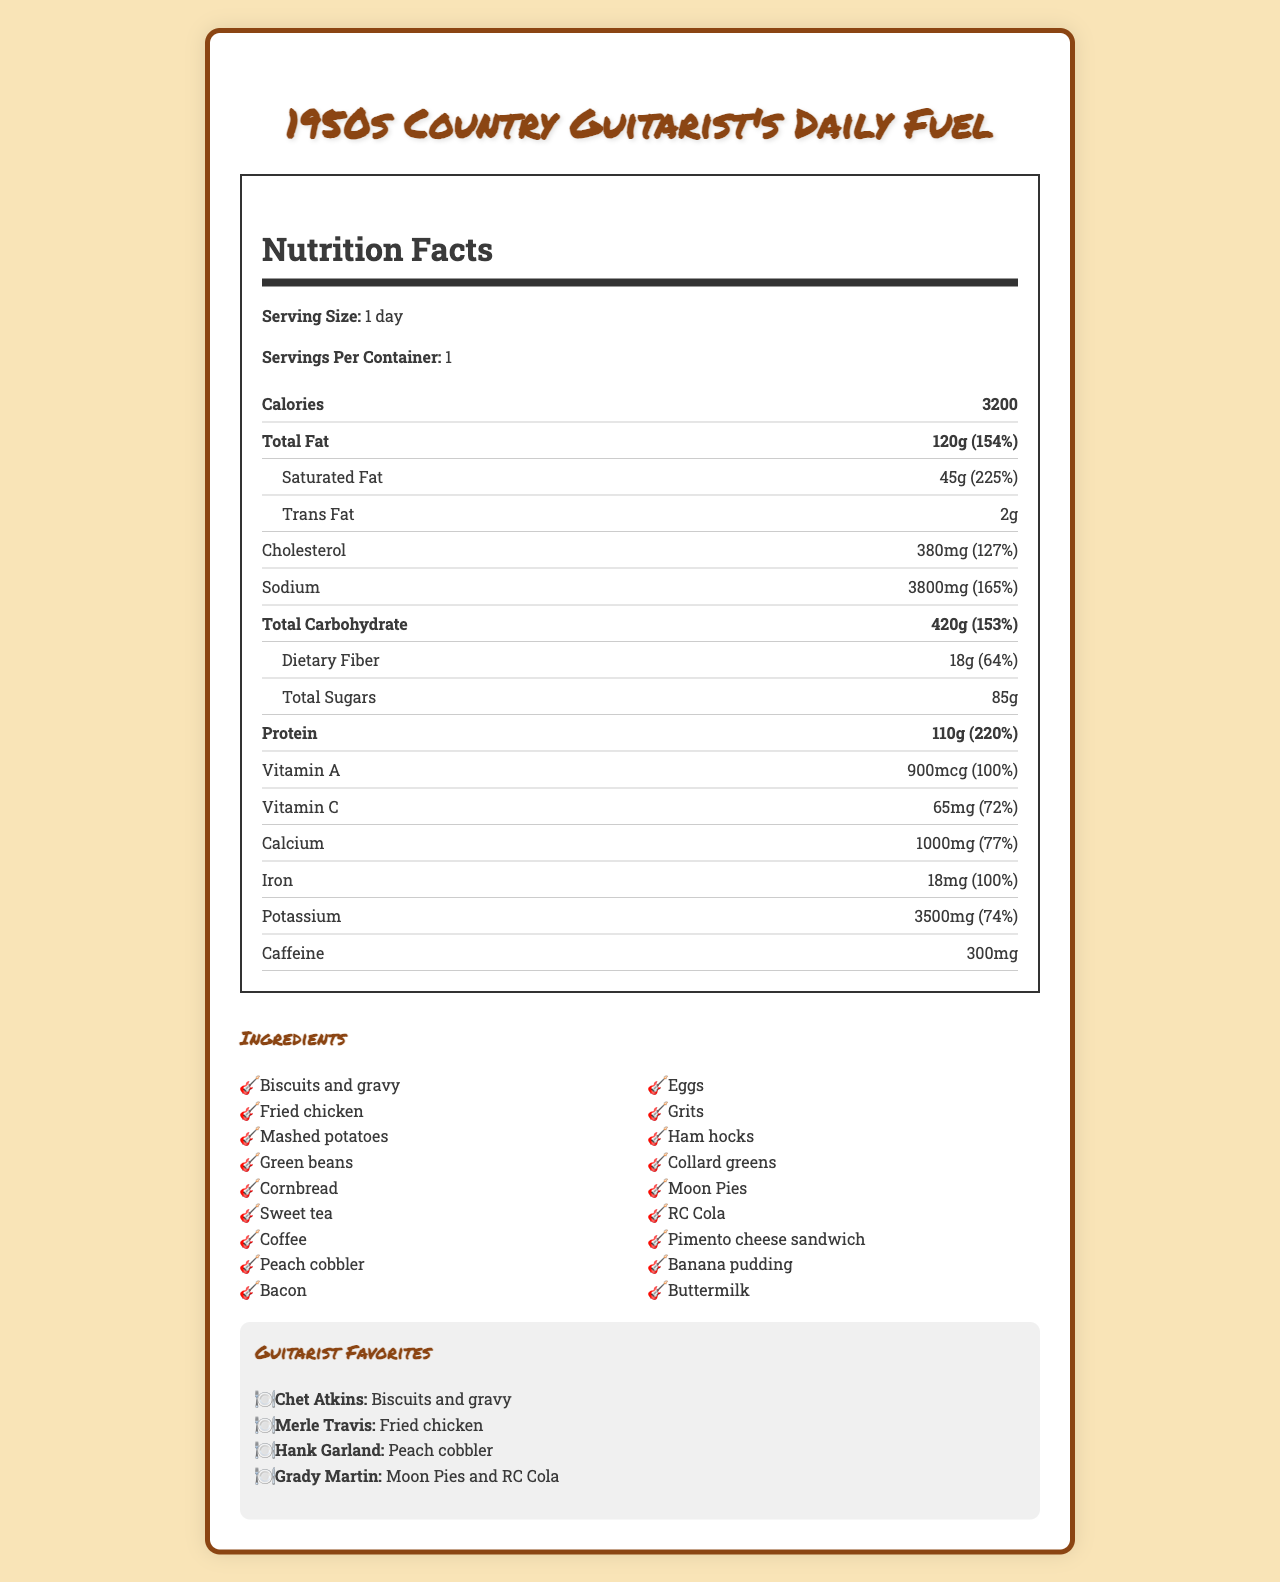what is the serving size? The document states that the serving size is "1 day."
Answer: 1 day how many calories does the 1950s country guitarist's daily fuel contain? The document lists the total calories as 3200.
Answer: 3200 what are the ingredients in this daily fuel? The Ingredients section lists all the ingredients included in the daily fuel.
Answer: Biscuits and gravy, Fried chicken, Mashed potatoes, Green beans, Cornbread, Sweet tea, Coffee, Peach cobbler, Bacon, Eggs, Grits, Ham hocks, Collard greens, Moon Pies, RC Cola, Pimento cheese sandwich, Banana pudding, Buttermilk which vitamin is provided at 100% daily value? The document indicates that Vitamin A is provided at 100% of the daily value with an amount of 900 mcg.
Answer: Vitamin A who preferred Moon Pies and RC Cola? In the Guitarist Favorites section, it mentions that Grady Martin's favorites are Moon Pies and RC Cola.
Answer: Grady Martin which post-show snack is listed in the document? 
A. Moon Pies
B. Biscuits and gravy
C. Banana pudding
D. Fried chicken The Post Show Snack section indicates that Banana pudding is the post-show snack.
Answer: C which guitarist's favorite is fried chicken?
I. Grady Martin
II. Hank Garland
III. Merle Travis In the Guitarist Favorites section, Merle Travis is listed as preferring fried chicken.
Answer: III is the sodium content higher than the cholesterol content? The sodium content is 3800 mg, which is higher than the cholesterol content of 380 mg.
Answer: Yes summarize the main idea of the document. The document contains comprehensive nutrition information, including calories, fats, proteins, vitamins, and minerals, along with a list of foods and beverages typical of a 1950s country musician's diet, favorite food items of specific guitarists, and essential meals and performance boosters.
Answer: The document provides detailed nutrition facts and ingredients for a typical daily diet of a 1950s country guitarist, highlighting high-calorie meals and favorite foods of iconic guitarists like Chet Atkins and Merle Travis, with a focus on performance-boosting nutrients, staple foods, and meals. what is the total amount of carbohydrates in the daily fuel? The document specifies that the total carbohydrate content is 420 grams.
Answer: 420 grams how much dietary fiber does this fuel provide? The document states that the dietary fiber content is 18 grams.
Answer: 18 grams what are the daily values of vitamin C and calcium provided by this diet? The document lists the daily value percentages for Vitamin C as 72% and for Calcium as 77%.
Answer: Vitamin C: 72%, Calcium: 77% how much caffeine is consumed from the daily fuel? The document indicates the caffeine content is 300 mg.
Answer: 300 mg is the serving size based on weekly consumption? The serving size is based on a single day, not weekly consumption.
Answer: No which foods are listed as tour bus staples in the document? The Tour Bus Staples section mentions these specific foods.
Answer: Pimento cheese sandwiches, Moon Pies, RC Cola, Thermos of coffee how many grams of total sugars are there in the daily fuel? The document specifies that there are 85 grams of total sugars.
Answer: 85 grams who among the guitarists mentioned preferred peach cobbler? In the Guitarist Favorites section, it lists Hank Garland as preferring peach cobbler.
Answer: Hank Garland how much protein does the 1950s country guitarist's daily fuel provide? The document states that the total protein content is 110 grams.
Answer: 110 grams what is the daily value percentage for sodium in this diet? The document indicates that the daily value percentage for sodium is 165%.
Answer: 165% which meal is suggested as the pre-show meal? The document suggests this combination as the pre-show meal.
Answer: Fried chicken, Mashed potatoes, and Sweet tea 